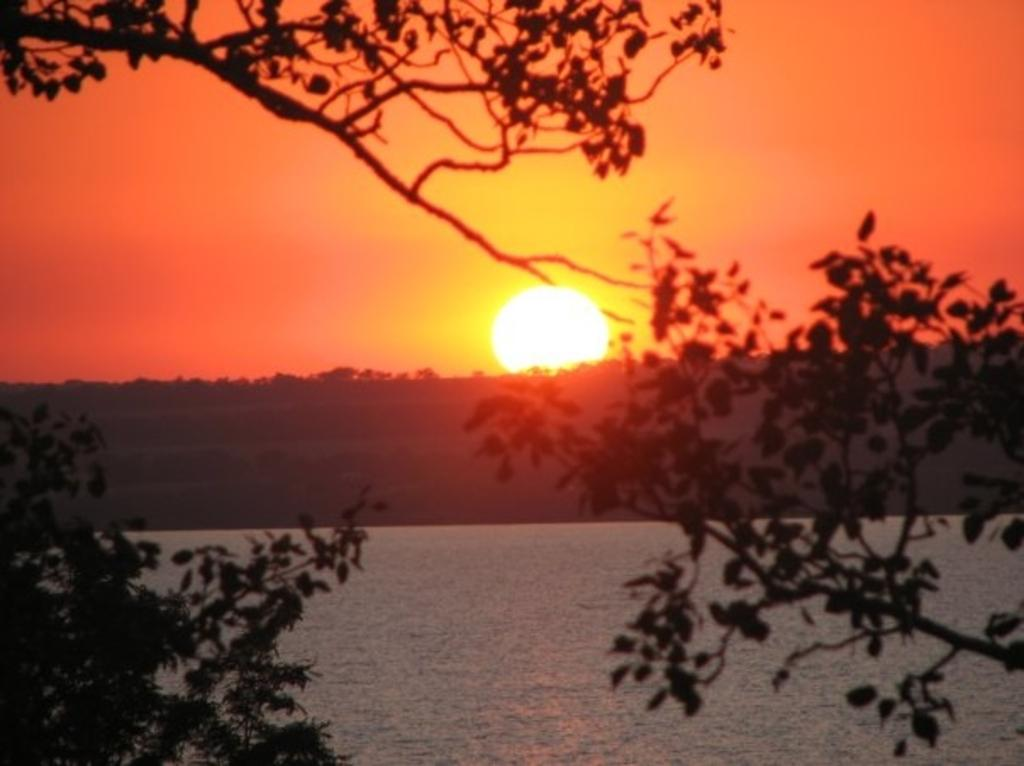What type of vegetation can be seen in the image? There are trees in the image. What natural element is visible in the image? There is water visible in the image. How many trees are present in the background of the image? There are many trees in the background of the image. What celestial body and atmospheric element can be seen in the background of the image? The sun and the sky are visible in the background of the image. What type of street can be seen in the image? There is no street present in the image; it features trees and water. How does the calculator help the trees in the image? There is no calculator present in the image, and therefore it cannot help the trees. 